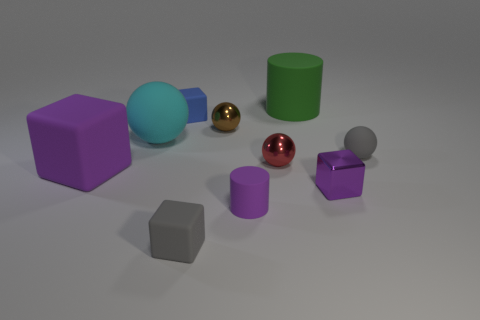Subtract all green blocks. Subtract all purple cylinders. How many blocks are left? 4 Subtract all balls. How many objects are left? 6 Add 6 green objects. How many green objects exist? 7 Subtract 0 yellow cylinders. How many objects are left? 10 Subtract all small shiny blocks. Subtract all red metallic balls. How many objects are left? 8 Add 8 red things. How many red things are left? 9 